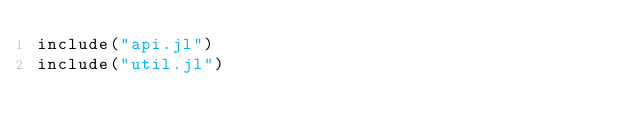<code> <loc_0><loc_0><loc_500><loc_500><_Julia_>include("api.jl")
include("util.jl")
</code> 